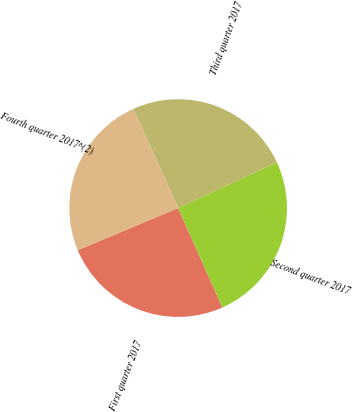Convert chart. <chart><loc_0><loc_0><loc_500><loc_500><pie_chart><fcel>First quarter 2017<fcel>Second quarter 2017<fcel>Third quarter 2017<fcel>Fourth quarter 2017^(2)<nl><fcel>25.35%<fcel>25.24%<fcel>24.82%<fcel>24.6%<nl></chart> 